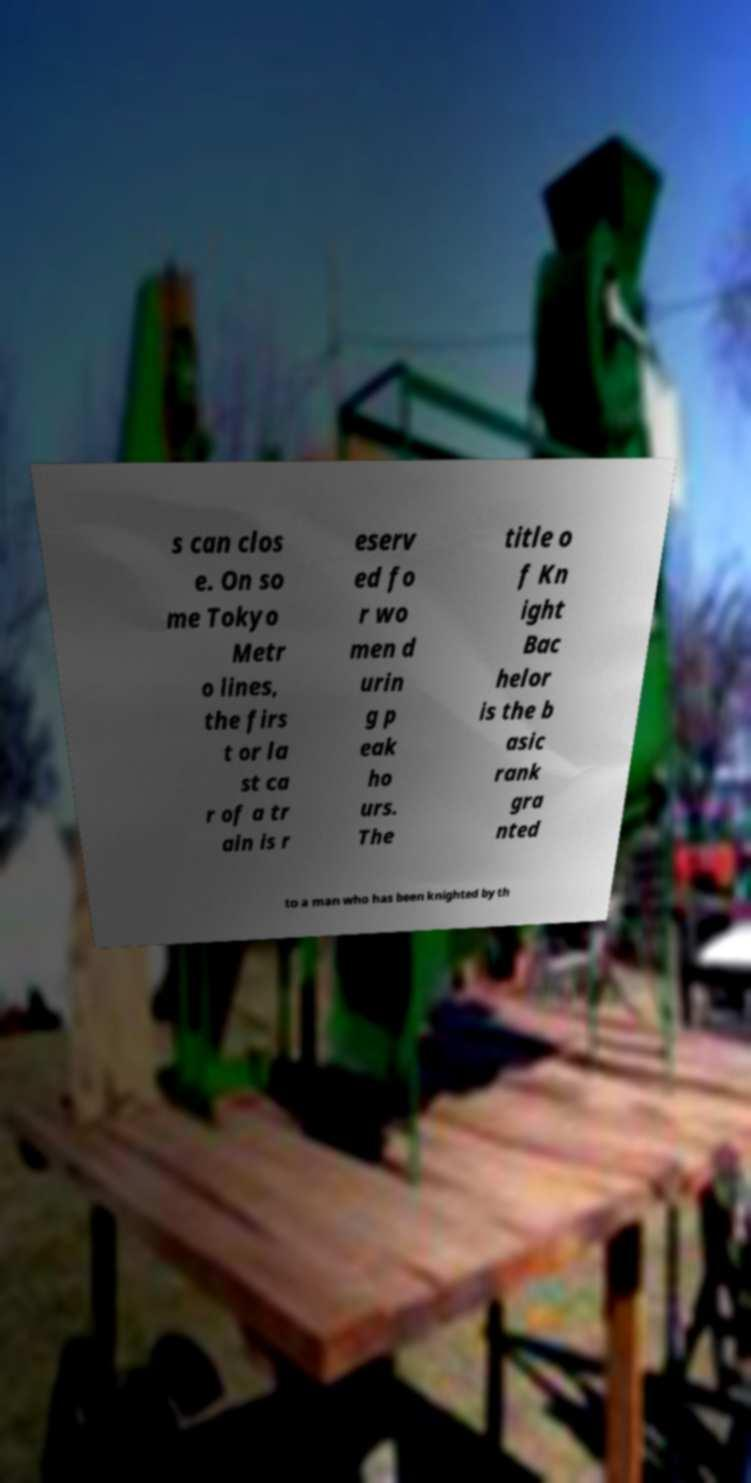Can you accurately transcribe the text from the provided image for me? s can clos e. On so me Tokyo Metr o lines, the firs t or la st ca r of a tr ain is r eserv ed fo r wo men d urin g p eak ho urs. The title o f Kn ight Bac helor is the b asic rank gra nted to a man who has been knighted by th 